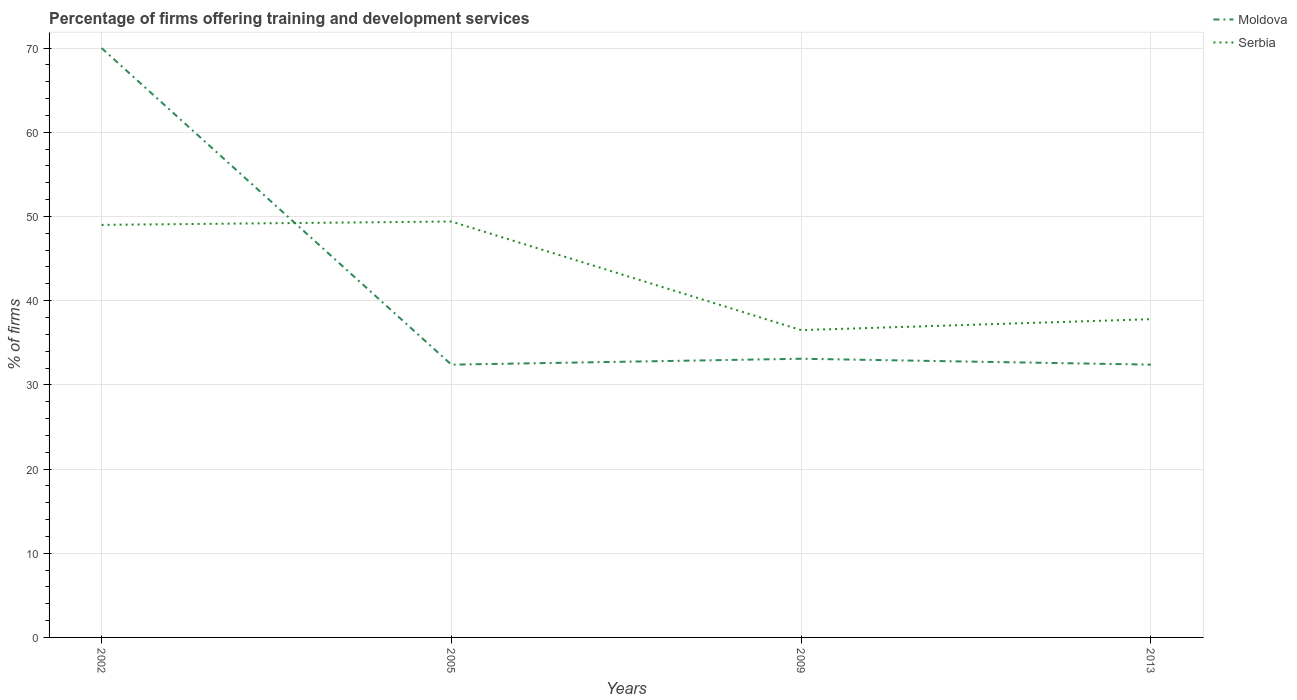Does the line corresponding to Serbia intersect with the line corresponding to Moldova?
Give a very brief answer. Yes. Is the number of lines equal to the number of legend labels?
Give a very brief answer. Yes. Across all years, what is the maximum percentage of firms offering training and development in Serbia?
Ensure brevity in your answer.  36.5. In which year was the percentage of firms offering training and development in Serbia maximum?
Give a very brief answer. 2009. What is the total percentage of firms offering training and development in Moldova in the graph?
Ensure brevity in your answer.  37.6. What is the difference between the highest and the second highest percentage of firms offering training and development in Serbia?
Make the answer very short. 12.9. What is the difference between the highest and the lowest percentage of firms offering training and development in Serbia?
Your answer should be compact. 2. Are the values on the major ticks of Y-axis written in scientific E-notation?
Keep it short and to the point. No. Does the graph contain any zero values?
Ensure brevity in your answer.  No. Does the graph contain grids?
Your response must be concise. Yes. How are the legend labels stacked?
Your response must be concise. Vertical. What is the title of the graph?
Offer a very short reply. Percentage of firms offering training and development services. Does "Bolivia" appear as one of the legend labels in the graph?
Offer a terse response. No. What is the label or title of the X-axis?
Offer a very short reply. Years. What is the label or title of the Y-axis?
Ensure brevity in your answer.  % of firms. What is the % of firms of Serbia in 2002?
Ensure brevity in your answer.  49. What is the % of firms of Moldova in 2005?
Make the answer very short. 32.4. What is the % of firms in Serbia in 2005?
Ensure brevity in your answer.  49.4. What is the % of firms in Moldova in 2009?
Provide a succinct answer. 33.1. What is the % of firms of Serbia in 2009?
Your response must be concise. 36.5. What is the % of firms in Moldova in 2013?
Keep it short and to the point. 32.4. What is the % of firms in Serbia in 2013?
Your answer should be very brief. 37.8. Across all years, what is the maximum % of firms of Serbia?
Provide a short and direct response. 49.4. Across all years, what is the minimum % of firms of Moldova?
Provide a succinct answer. 32.4. Across all years, what is the minimum % of firms of Serbia?
Your response must be concise. 36.5. What is the total % of firms of Moldova in the graph?
Your answer should be very brief. 167.9. What is the total % of firms in Serbia in the graph?
Your response must be concise. 172.7. What is the difference between the % of firms in Moldova in 2002 and that in 2005?
Offer a terse response. 37.6. What is the difference between the % of firms in Moldova in 2002 and that in 2009?
Make the answer very short. 36.9. What is the difference between the % of firms in Serbia in 2002 and that in 2009?
Your answer should be compact. 12.5. What is the difference between the % of firms in Moldova in 2002 and that in 2013?
Offer a very short reply. 37.6. What is the difference between the % of firms of Serbia in 2002 and that in 2013?
Provide a short and direct response. 11.2. What is the difference between the % of firms in Moldova in 2005 and that in 2009?
Provide a succinct answer. -0.7. What is the difference between the % of firms in Moldova in 2005 and that in 2013?
Offer a very short reply. 0. What is the difference between the % of firms in Moldova in 2002 and the % of firms in Serbia in 2005?
Ensure brevity in your answer.  20.6. What is the difference between the % of firms of Moldova in 2002 and the % of firms of Serbia in 2009?
Provide a short and direct response. 33.5. What is the difference between the % of firms in Moldova in 2002 and the % of firms in Serbia in 2013?
Ensure brevity in your answer.  32.2. What is the difference between the % of firms of Moldova in 2005 and the % of firms of Serbia in 2013?
Your answer should be compact. -5.4. What is the difference between the % of firms in Moldova in 2009 and the % of firms in Serbia in 2013?
Offer a terse response. -4.7. What is the average % of firms in Moldova per year?
Ensure brevity in your answer.  41.98. What is the average % of firms in Serbia per year?
Offer a terse response. 43.17. What is the ratio of the % of firms of Moldova in 2002 to that in 2005?
Keep it short and to the point. 2.16. What is the ratio of the % of firms of Moldova in 2002 to that in 2009?
Ensure brevity in your answer.  2.11. What is the ratio of the % of firms in Serbia in 2002 to that in 2009?
Your answer should be compact. 1.34. What is the ratio of the % of firms in Moldova in 2002 to that in 2013?
Ensure brevity in your answer.  2.16. What is the ratio of the % of firms in Serbia in 2002 to that in 2013?
Ensure brevity in your answer.  1.3. What is the ratio of the % of firms of Moldova in 2005 to that in 2009?
Ensure brevity in your answer.  0.98. What is the ratio of the % of firms in Serbia in 2005 to that in 2009?
Ensure brevity in your answer.  1.35. What is the ratio of the % of firms of Serbia in 2005 to that in 2013?
Offer a very short reply. 1.31. What is the ratio of the % of firms of Moldova in 2009 to that in 2013?
Your response must be concise. 1.02. What is the ratio of the % of firms of Serbia in 2009 to that in 2013?
Keep it short and to the point. 0.97. What is the difference between the highest and the second highest % of firms in Moldova?
Your answer should be compact. 36.9. What is the difference between the highest and the lowest % of firms in Moldova?
Keep it short and to the point. 37.6. What is the difference between the highest and the lowest % of firms of Serbia?
Your answer should be compact. 12.9. 